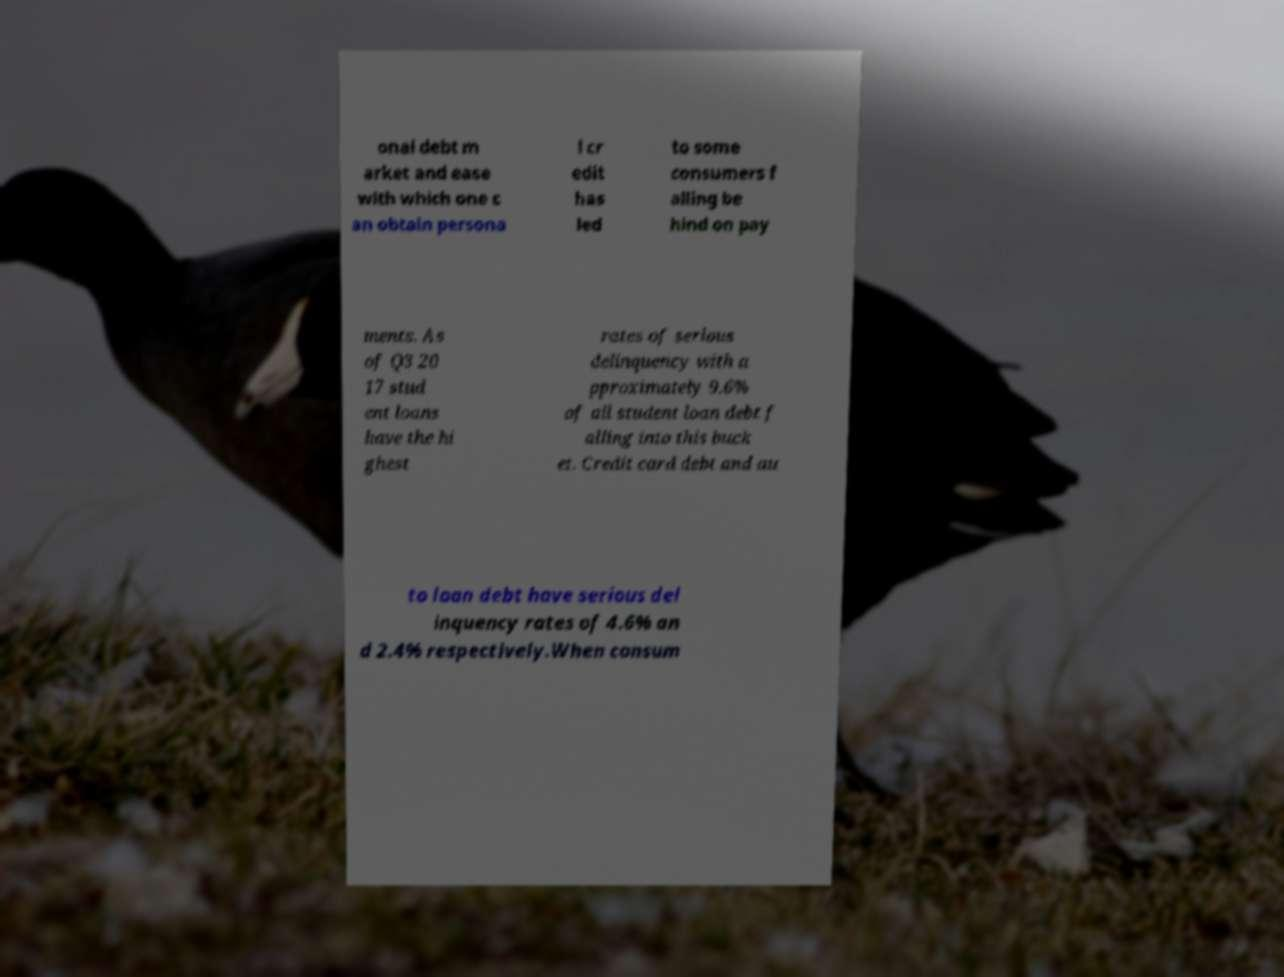Could you assist in decoding the text presented in this image and type it out clearly? onal debt m arket and ease with which one c an obtain persona l cr edit has led to some consumers f alling be hind on pay ments. As of Q3 20 17 stud ent loans have the hi ghest rates of serious delinquency with a pproximately 9.6% of all student loan debt f alling into this buck et. Credit card debt and au to loan debt have serious del inquency rates of 4.6% an d 2.4% respectively.When consum 